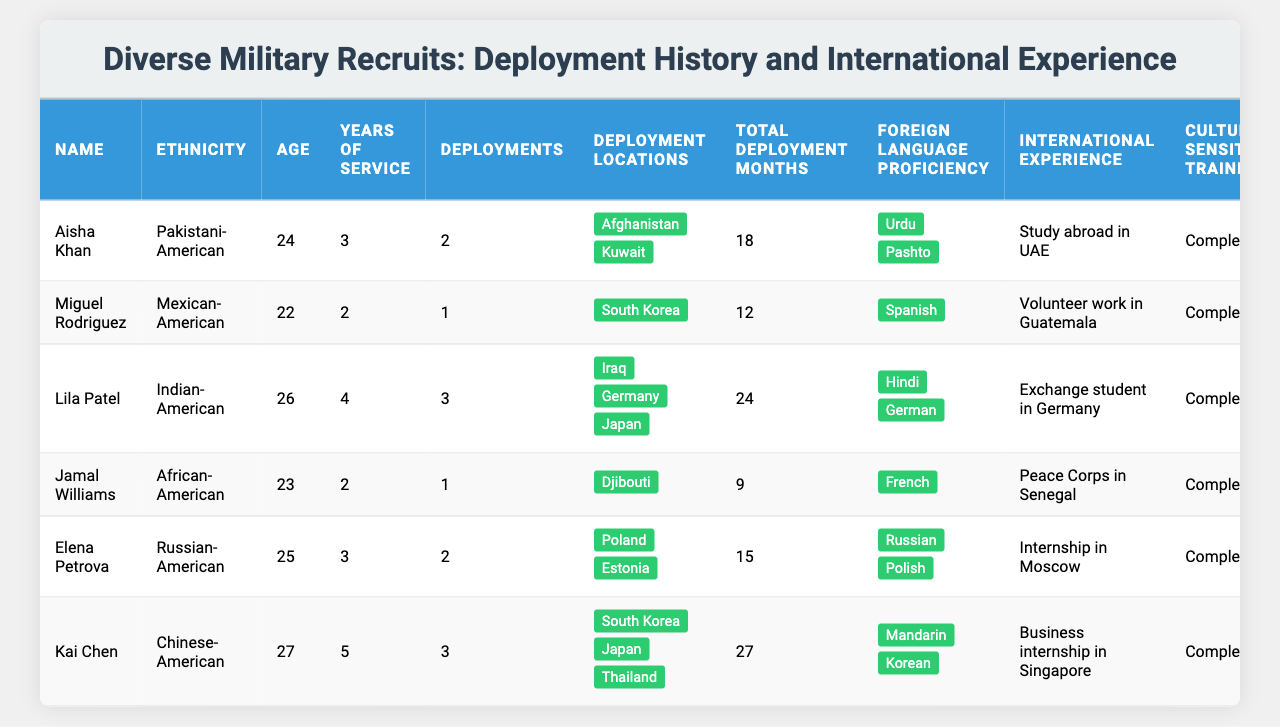What is the total number of deployments among the recruits? To find the total number of deployments, I will add the deployments from all recruits: 2 (Aisha) + 1 (Miguel) + 3 (Lila) + 1 (Jamal) + 2 (Elena) + 3 (Kai) = 12 total deployments.
Answer: 12 Which recruit has the highest Cross-Cultural Communication Score? By examining the Cross-Cultural Communication Scores, I see that Kai Chen has the highest score of 97. No other recruit exceeds this score.
Answer: Kai Chen How many recruits have completed Cultural Sensitivity Training? All recruits listed completed Cultural Sensitivity Training, so I can count them. There are 6 recruits in total, all of whom have completed this training.
Answer: 6 What is the average age of all the recruits? To calculate the average age, I will sum up the ages: 24 (Aisha) + 22 (Miguel) + 26 (Lila) + 23 (Jamal) + 25 (Elena) + 27 (Kai) = 147. There are 6 recruits, so the average age is 147 / 6 = 24.5.
Answer: 24.5 Which locations did Lila Patel deploy to? The table provides Lila's deployment locations as Iraq, Germany, and Japan. I can verify these directly from the deployment locations listed in her row.
Answer: Iraq, Germany, Japan Is there a recruit who is proficient in more than two foreign languages? After checking each recruit, I see that none of them are proficient in more than two languages. The maximum proficiency listed is two (for Aisha, Lila, Elena, Kai).
Answer: No How many months of total deployments does Kai Chen have compared to the average of all recruits? Kai Chen has 27 total deployment months. For the average, I first sum total deployment months: 18 + 12 + 24 + 9 + 15 + 27 = 105. The average is 105 / 6 = 17.5. Kai's 27 is greater than 17.5.
Answer: 27 months compared to 17.5 months Which ethnic group has the highest average Cross-Cultural Communication Score? To find this, I calculate the average score for each ethnic group: Pakistani-American (92), Mexican-American (88), Indian-American (95), African-American (91), Russian-American (93), and Chinese-American (97). The highest average is from Chinese-American (97).
Answer: Chinese-American What percentage of recruits have deployment experience in Asia? I observe that Aisha deployed to Kuwait (not in Asia), Miguel to South Korea, Lila to Germany and Japan, Jamal to Djibouti, Elena to Poland and Estonia, and Kai to South Korea, Japan, and Thailand. Counting, 4 out of 6 recruits have experience in Asia. 4/6, or 66.67%, have deployment experience in Asia.
Answer: 66.67% Does any recruit have international experience listed in more than one location? By checking the international experience values, I see that all recruits have unique international experiences in one location each. Thus, no recruit has experience in more than one location.
Answer: No 